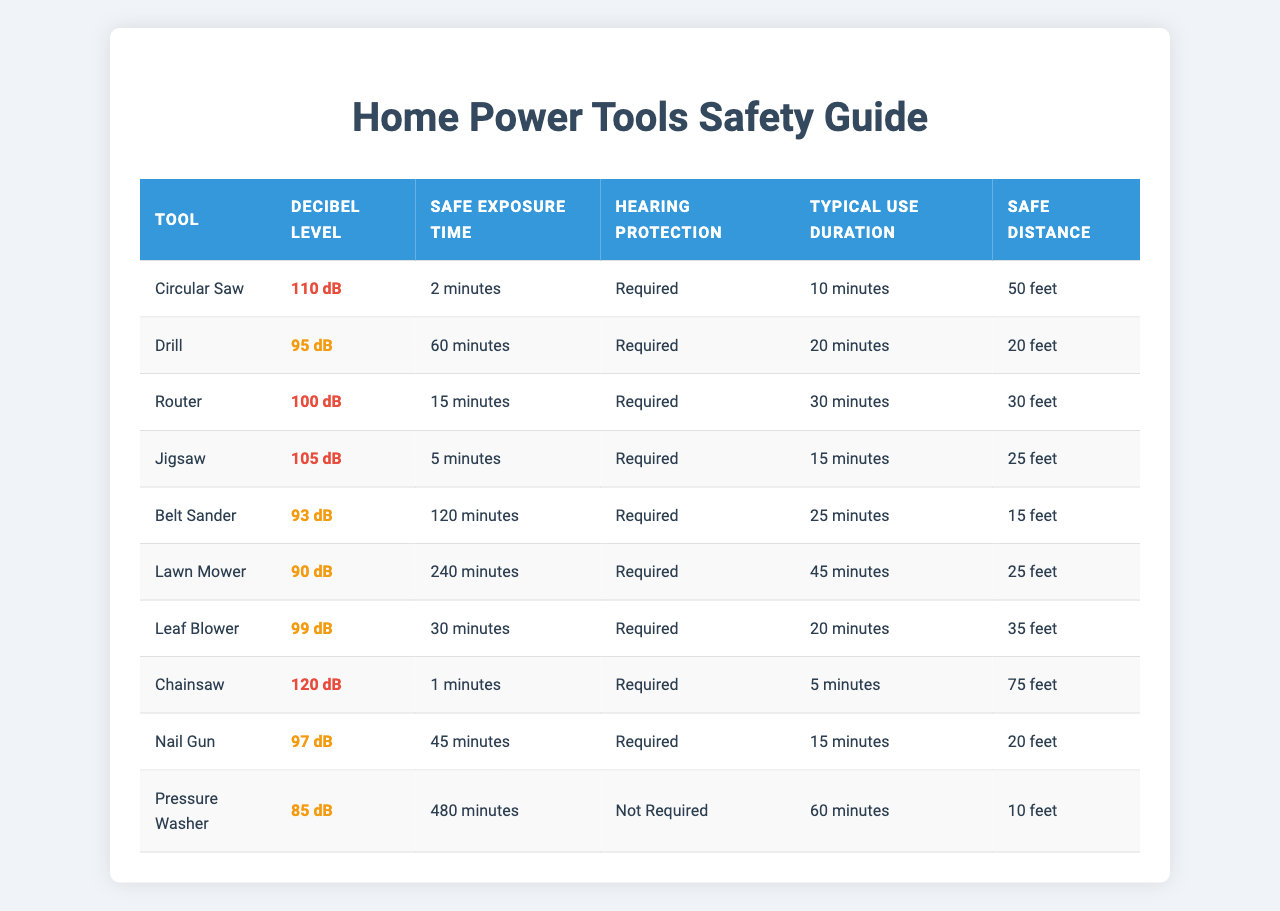What is the decibel level of the Chainsaw? The table lists the decibel levels for each tool, and the Chainsaw is listed next to its decibel level of 120 dB.
Answer: 120 dB Which tool requires the shortest safe exposure time? Reviewing the table, the Chainsaw has the shortest safe exposure time of 1 minute, which is less than any other tool listed.
Answer: Chainsaw How many tools require hearing protection? Counting the 'Hearing Protection' column, all tools except for the Pressure Washer require hearing protection, which totals to 9 tools.
Answer: 9 tools What is the typical use duration for the Circular Saw? The table specifies the typical use duration for the Circular Saw as 10 minutes, directly indicated in the corresponding column.
Answer: 10 minutes Which tool has the longest typical use duration? The table shows that the Pressure Washer has the longest typical use duration of 60 minutes, which is the highest value compared to other tools.
Answer: Pressure Washer What is the average decibel level for the tools? First, add all the decibel levels together: 110 + 95 + 100 + 105 + 93 + 90 + 99 + 120 + 97 + 85 = 1094. Then divide this total by the number of tools (10) to find the average: 1094 / 10 = 109.4.
Answer: 109.4 dB Is it safe to operate the Lawn Mower for 45 minutes without hearing protection? The safe exposure time for the Lawn Mower is 240 minutes, so operating it for 45 minutes is well within the safe limits, as 45 minutes is less than 240 minutes.
Answer: Yes What is the difference in safe exposure time between the Lawn Mower and the Chainsaw? The safe exposure time for the Lawn Mower is 240 minutes while for the Chainsaw it is 1 minute. The difference is calculated as 240 - 1 = 239 minutes.
Answer: 239 minutes Which tool can be used the longest without hearing protection? The table shows that the Pressure Washer does not require hearing protection and has a safe exposure time of 480 minutes, which is the longest duration.
Answer: Pressure Washer How many feet away should I be from the Leaf Blower for safe hearing? Looking at the table, the distance for safe hearing from the Leaf Blower is listed as 35 feet.
Answer: 35 feet 